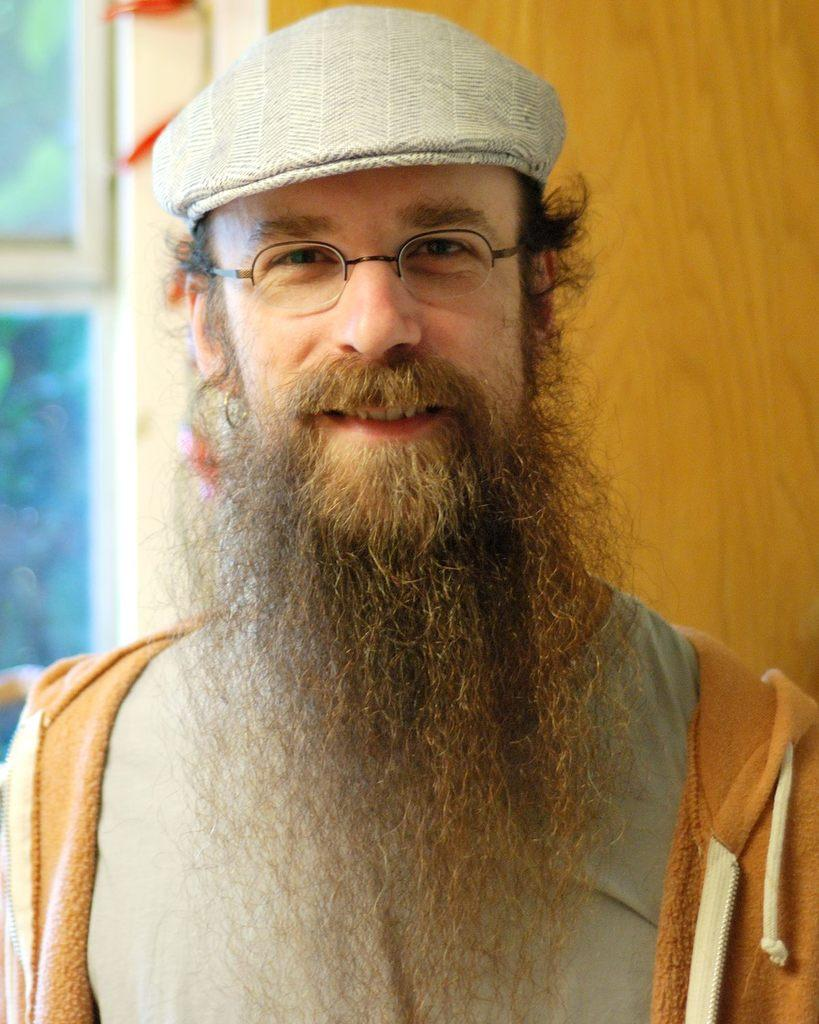What is the main subject of the image? There is a person in the image. Can you describe the person's attire? The person is wearing a cap and spectacles. What is the person's facial expression? The person is smiling. What can be seen in the background of the image? There are objects in the background of the image. What type of boot is the person wearing in the image? There is no boot visible in the image; the person is wearing a cap and spectacles. Can you tell me how many friends are present in the image? There is no mention of friends in the image; it only features a person wearing a cap and spectacles. 